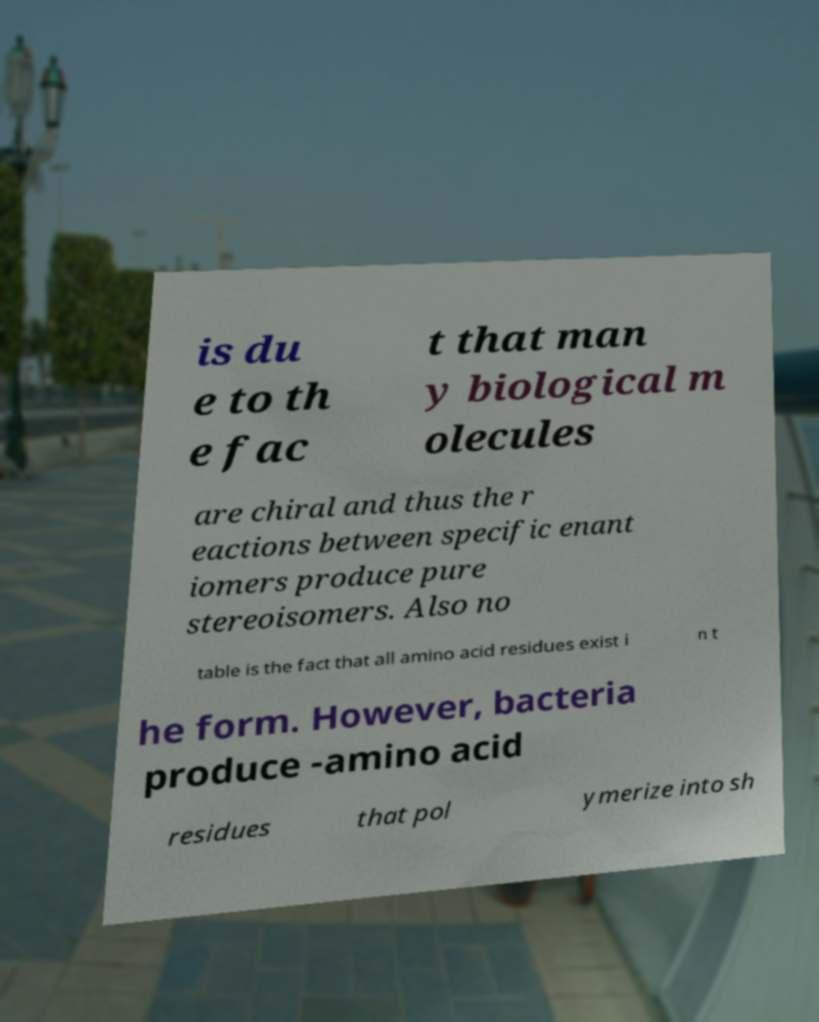Could you assist in decoding the text presented in this image and type it out clearly? is du e to th e fac t that man y biological m olecules are chiral and thus the r eactions between specific enant iomers produce pure stereoisomers. Also no table is the fact that all amino acid residues exist i n t he form. However, bacteria produce -amino acid residues that pol ymerize into sh 